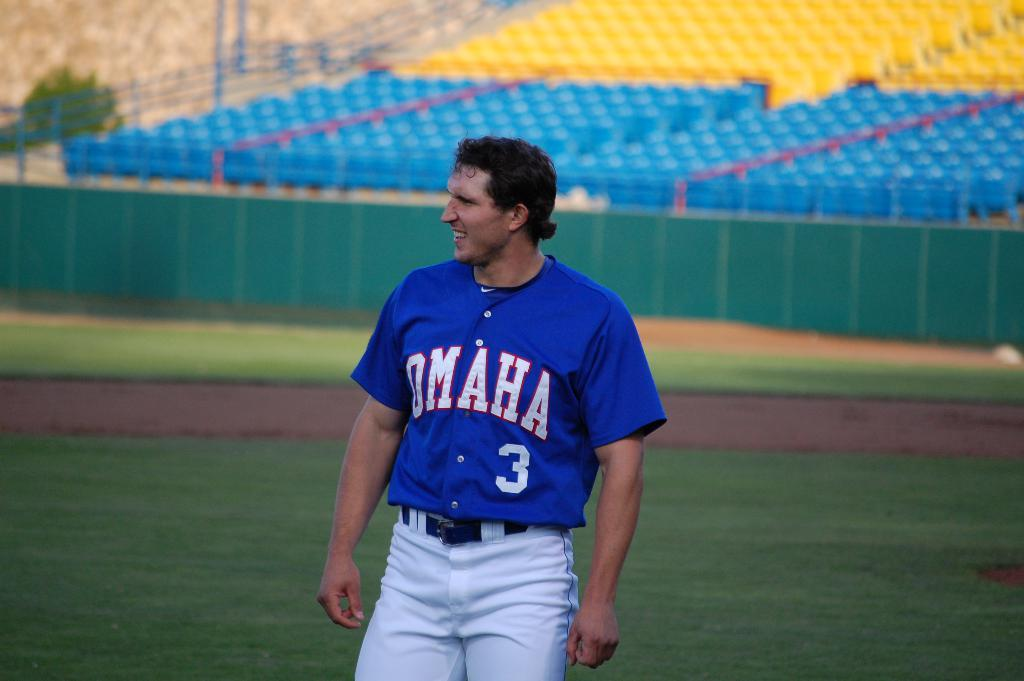<image>
Render a clear and concise summary of the photo. The number 3 baseball player for Omaha is standing on a field. 